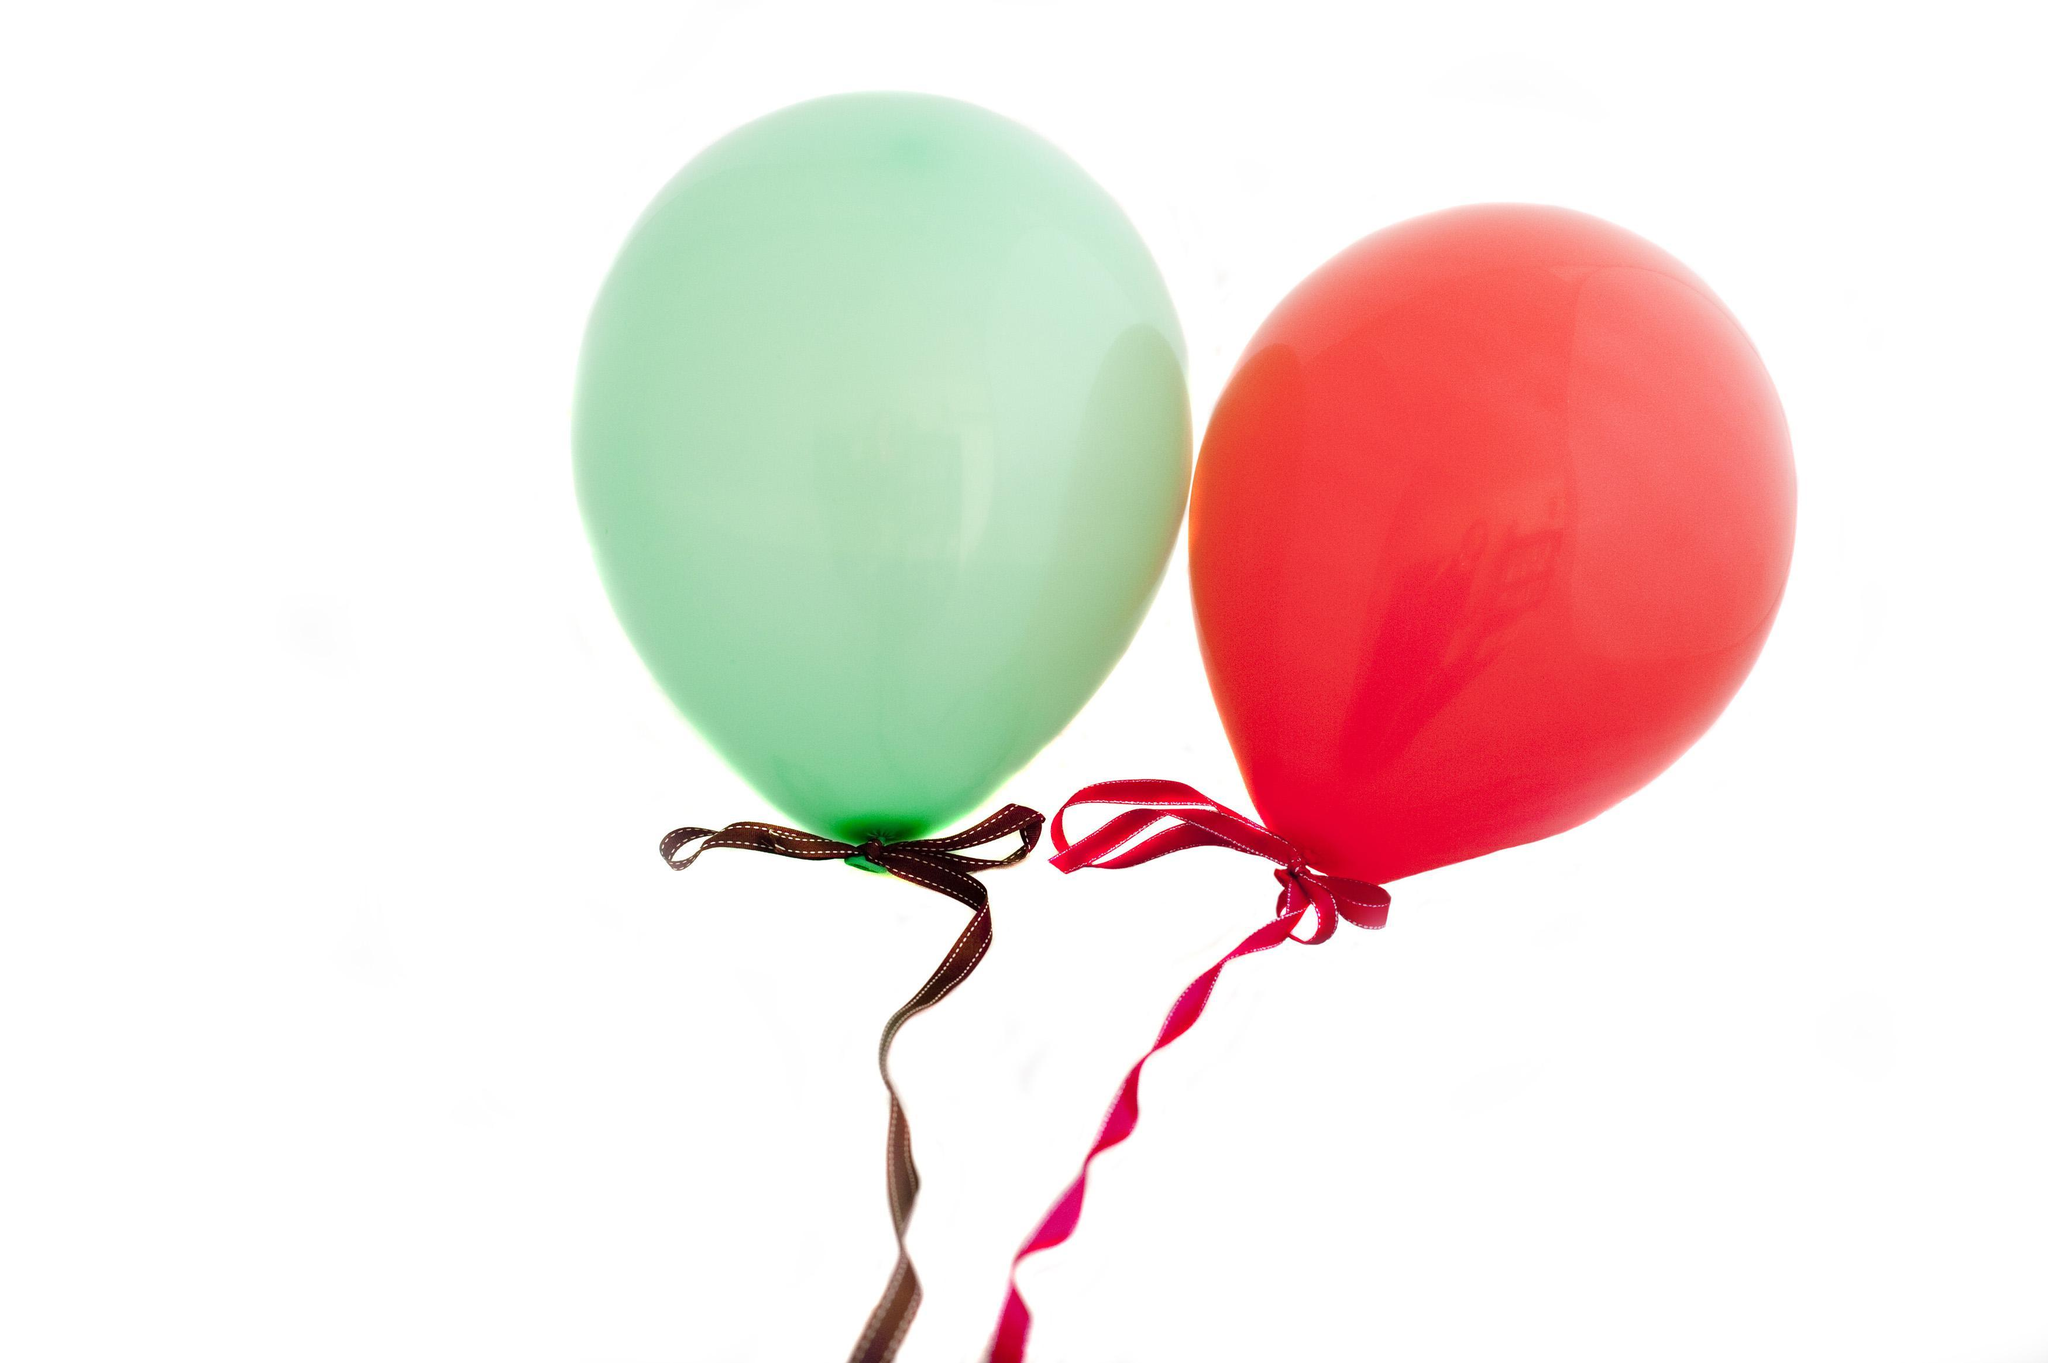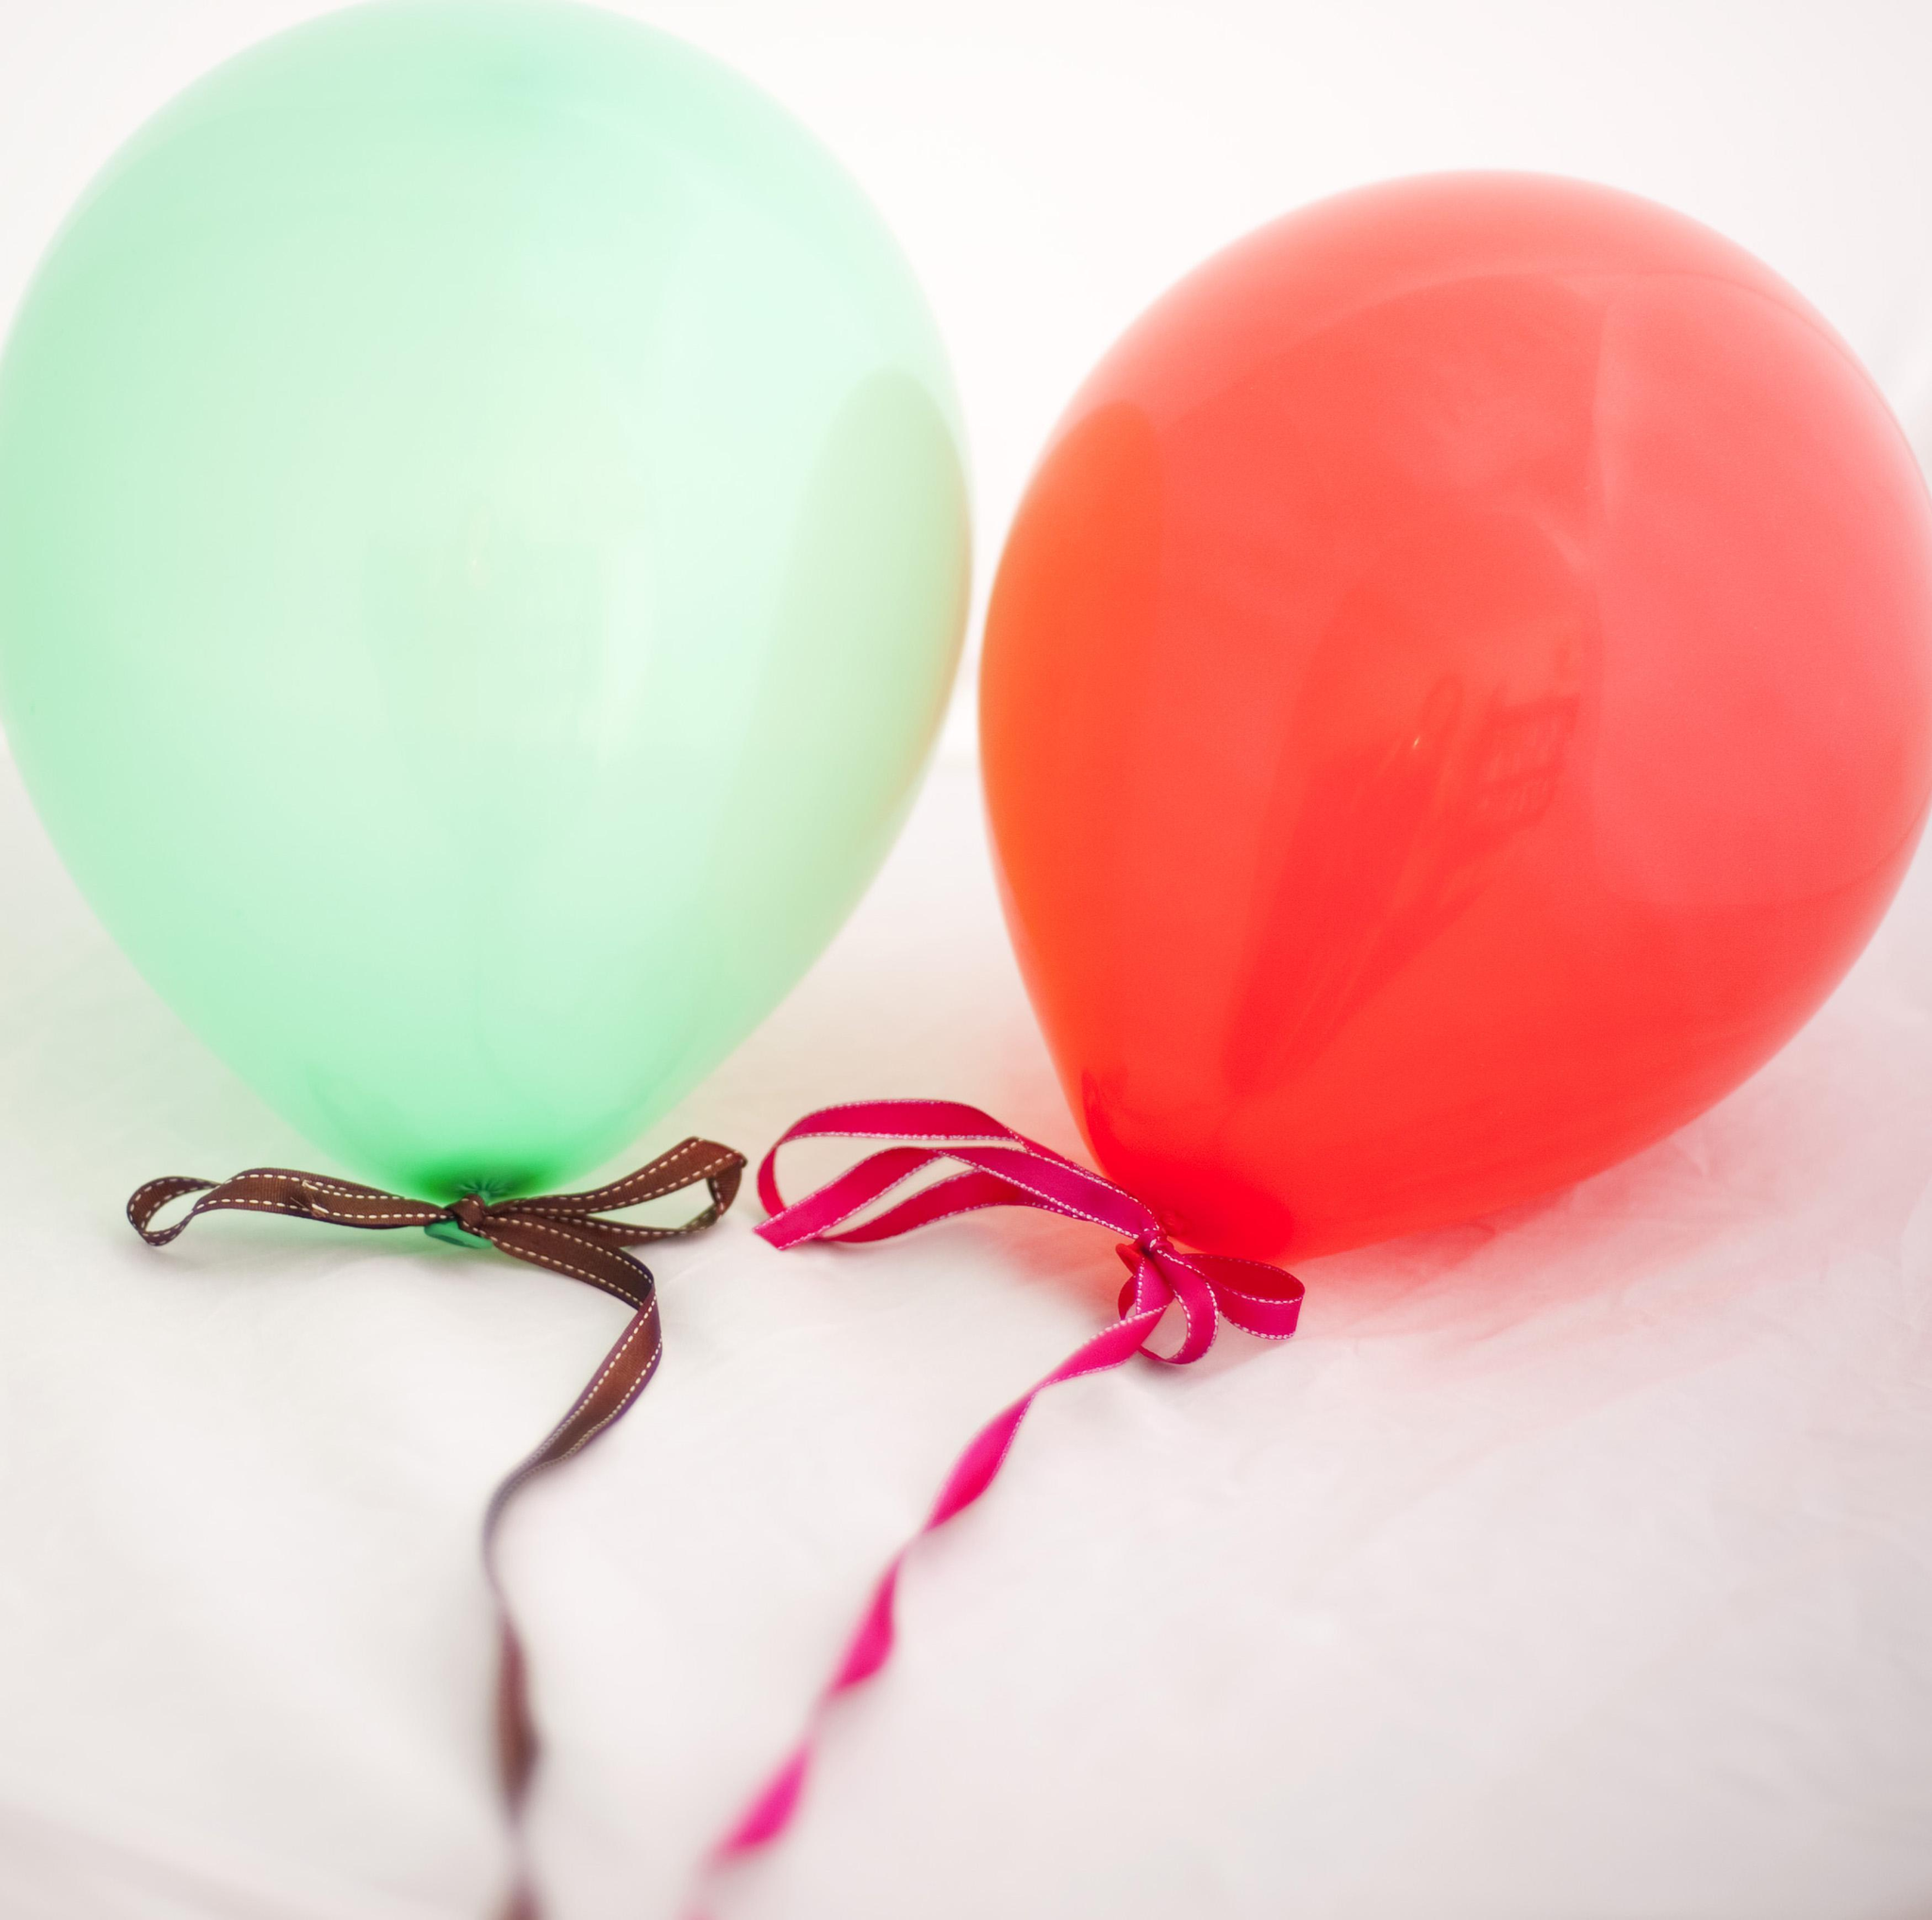The first image is the image on the left, the second image is the image on the right. Examine the images to the left and right. Is the description "Each image shows exactly one aqua balloon next to one red balloon." accurate? Answer yes or no. Yes. The first image is the image on the left, the second image is the image on the right. Analyze the images presented: Is the assertion "Each image shows one round red balloon and one round green balloon side by side" valid? Answer yes or no. Yes. 